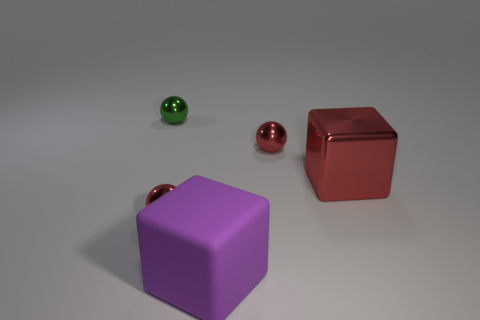Add 5 big matte spheres. How many objects exist? 10 Subtract all spheres. How many objects are left? 2 Subtract all big metallic things. Subtract all big metal cubes. How many objects are left? 3 Add 2 large metal cubes. How many large metal cubes are left? 3 Add 1 big metallic blocks. How many big metallic blocks exist? 2 Subtract 0 cyan cubes. How many objects are left? 5 